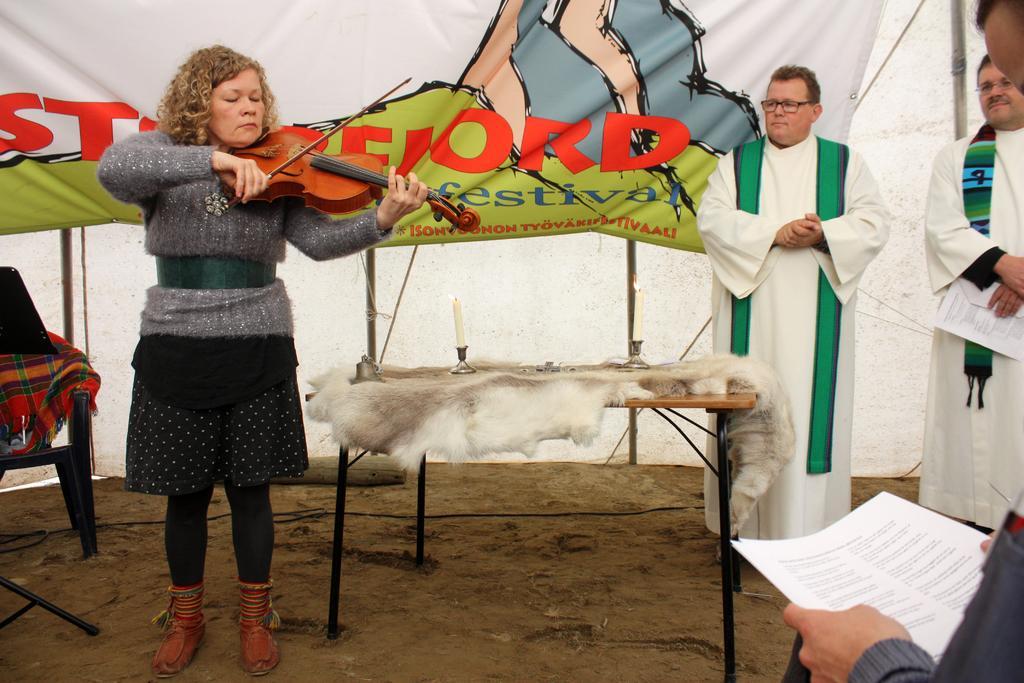Could you give a brief overview of what you see in this image? There is a woman in the left, she is playing violin. There is a chair behind the women, at the back there is a banner in the middle there is a table, there is a candle on a table. At the bottom there is a wire, at the right two people wearing white color dress and at the front there is a person holding paper. 